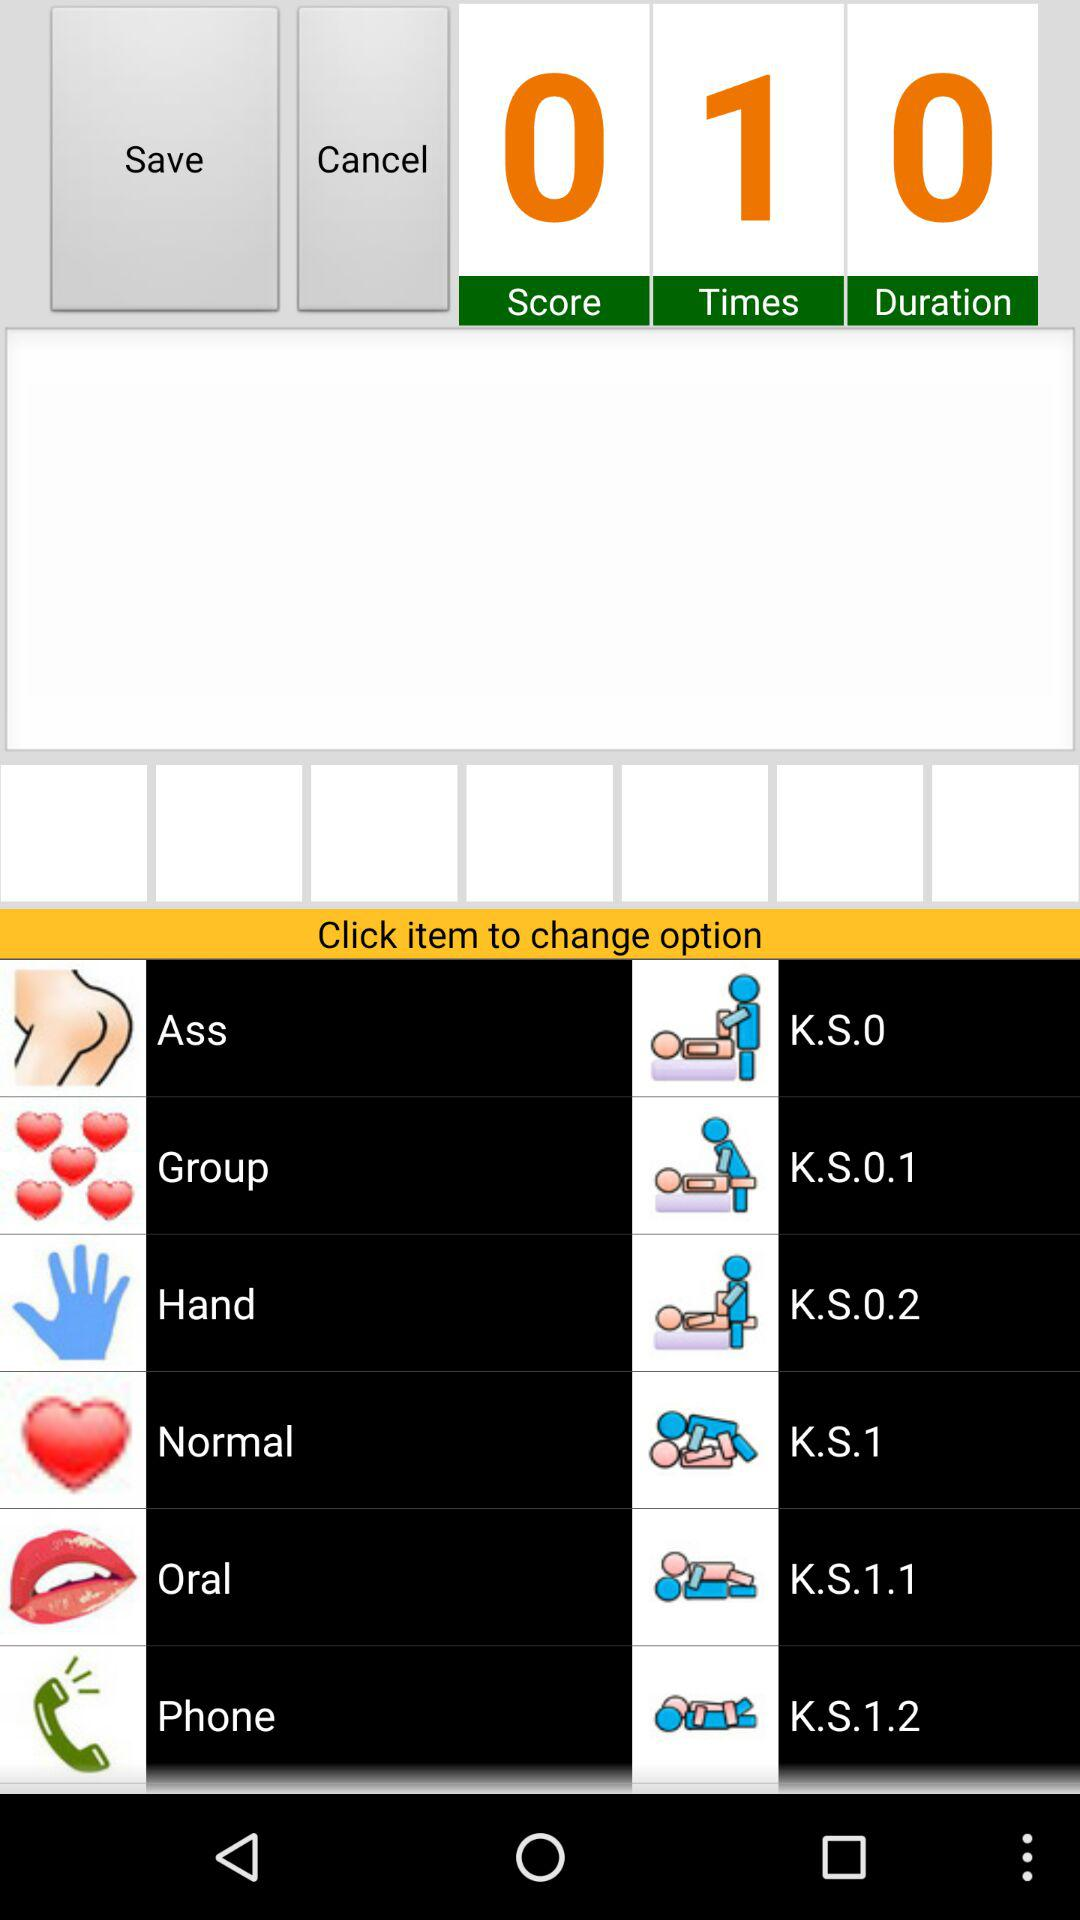How many times was the activity performed? The activity was performed once. 